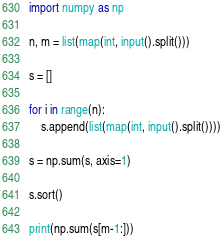<code> <loc_0><loc_0><loc_500><loc_500><_Python_>import numpy as np

n, m = list(map(int, input().split()))

s = []

for i in range(n):
    s.append(list(map(int, input().split())))
    
s = np.sum(s, axis=1)

s.sort()

print(np.sum(s[m-1:]))</code> 